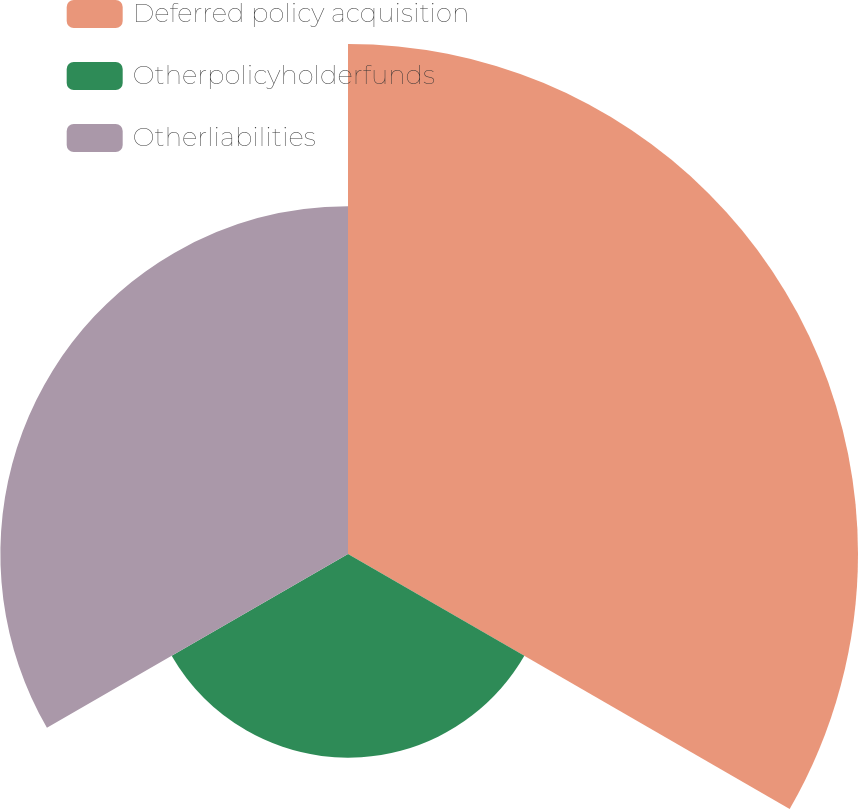Convert chart. <chart><loc_0><loc_0><loc_500><loc_500><pie_chart><fcel>Deferred policy acquisition<fcel>Otherpolicyholderfunds<fcel>Otherliabilities<nl><fcel>48.06%<fcel>19.19%<fcel>32.76%<nl></chart> 